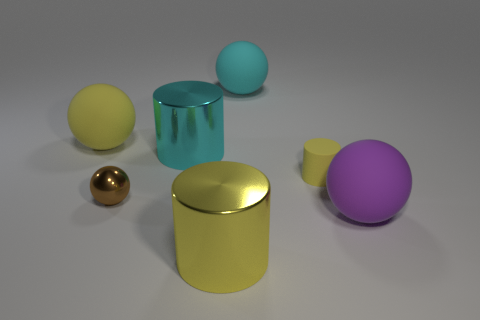Is the number of purple rubber objects less than the number of shiny cylinders?
Your answer should be very brief. Yes. How many other things are the same color as the tiny sphere?
Your answer should be compact. 0. What number of big metal things are there?
Your answer should be compact. 2. Are there fewer yellow rubber cylinders to the left of the tiny yellow cylinder than spheres?
Offer a very short reply. Yes. Is the material of the large cylinder that is on the left side of the large yellow cylinder the same as the brown ball?
Your response must be concise. Yes. There is a big yellow object that is behind the large rubber ball right of the rubber thing that is behind the big yellow matte ball; what shape is it?
Offer a very short reply. Sphere. Is there a purple matte sphere of the same size as the rubber cylinder?
Provide a succinct answer. No. How big is the purple rubber sphere?
Give a very brief answer. Large. How many other yellow shiny objects have the same size as the yellow shiny object?
Offer a very short reply. 0. Is the number of small balls on the left side of the big yellow sphere less than the number of large metal cylinders that are on the right side of the matte cylinder?
Make the answer very short. No. 